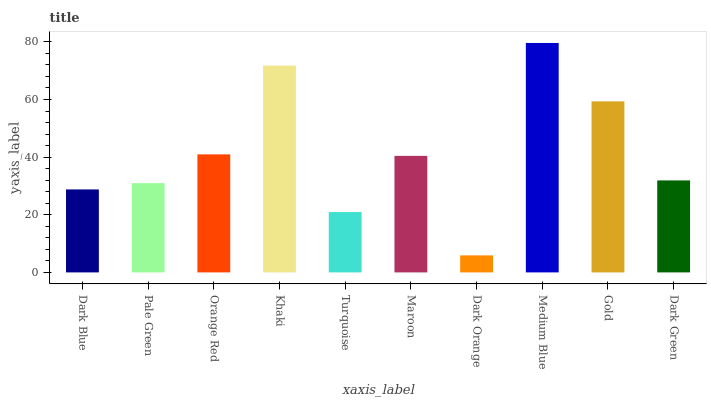Is Dark Orange the minimum?
Answer yes or no. Yes. Is Medium Blue the maximum?
Answer yes or no. Yes. Is Pale Green the minimum?
Answer yes or no. No. Is Pale Green the maximum?
Answer yes or no. No. Is Pale Green greater than Dark Blue?
Answer yes or no. Yes. Is Dark Blue less than Pale Green?
Answer yes or no. Yes. Is Dark Blue greater than Pale Green?
Answer yes or no. No. Is Pale Green less than Dark Blue?
Answer yes or no. No. Is Maroon the high median?
Answer yes or no. Yes. Is Dark Green the low median?
Answer yes or no. Yes. Is Orange Red the high median?
Answer yes or no. No. Is Medium Blue the low median?
Answer yes or no. No. 